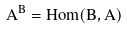<formula> <loc_0><loc_0><loc_500><loc_500>A ^ { B } = H o m ( B , A )</formula> 